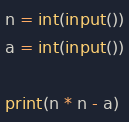Convert code to text. <code><loc_0><loc_0><loc_500><loc_500><_Python_>n = int(input())
a = int(input())

print(n * n - a)</code> 